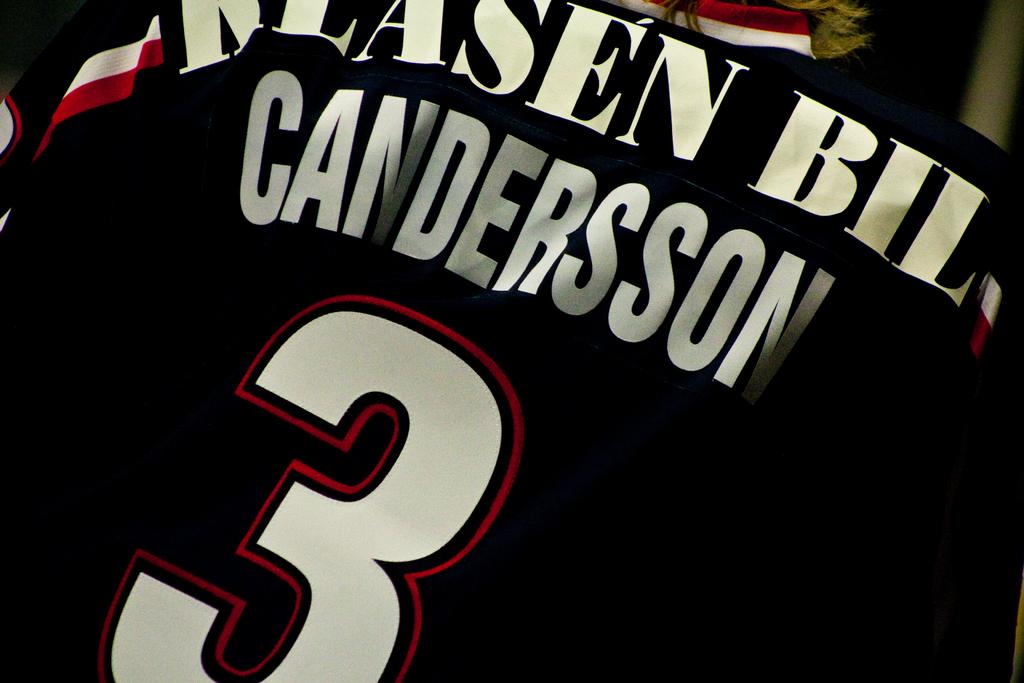What number would this player be representing?
Your answer should be compact. 3. That playe rwas represented number 3?
Your answer should be very brief. Candersson. 